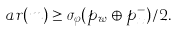<formula> <loc_0><loc_0><loc_500><loc_500>\ a r ( m ) \geq \sigma _ { \varphi } ( p _ { w } \oplus p _ { x } ^ { - } ) / 2 .</formula> 